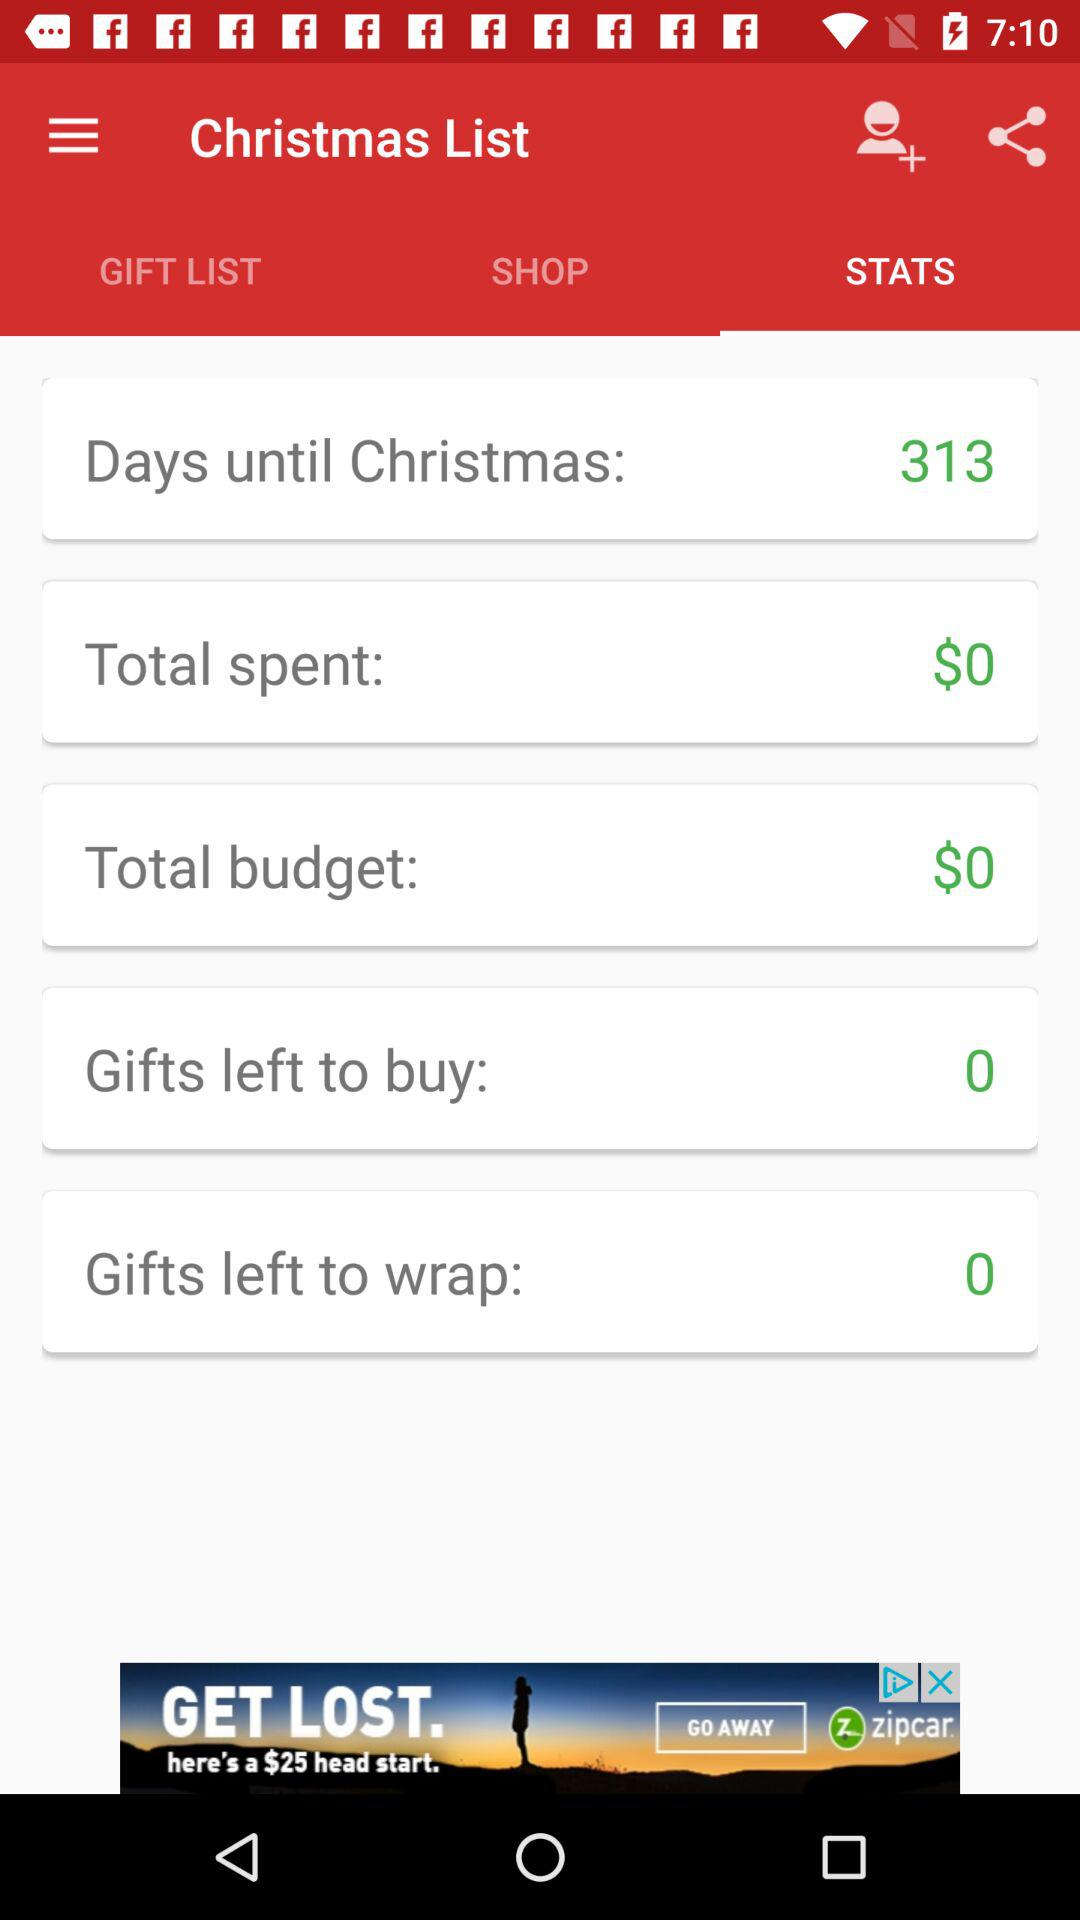What is the total budget? The total budget is $0. 